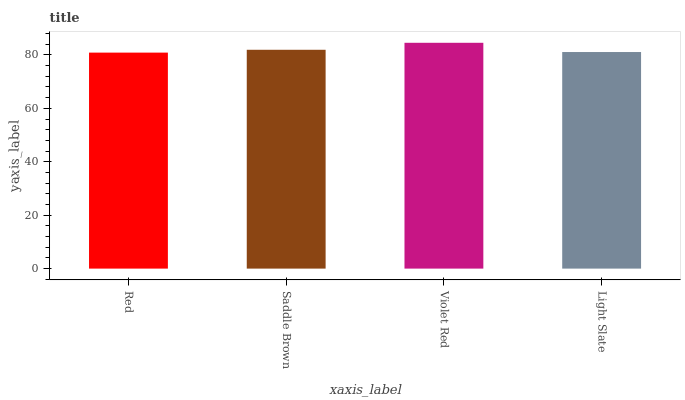Is Red the minimum?
Answer yes or no. Yes. Is Violet Red the maximum?
Answer yes or no. Yes. Is Saddle Brown the minimum?
Answer yes or no. No. Is Saddle Brown the maximum?
Answer yes or no. No. Is Saddle Brown greater than Red?
Answer yes or no. Yes. Is Red less than Saddle Brown?
Answer yes or no. Yes. Is Red greater than Saddle Brown?
Answer yes or no. No. Is Saddle Brown less than Red?
Answer yes or no. No. Is Saddle Brown the high median?
Answer yes or no. Yes. Is Light Slate the low median?
Answer yes or no. Yes. Is Violet Red the high median?
Answer yes or no. No. Is Saddle Brown the low median?
Answer yes or no. No. 